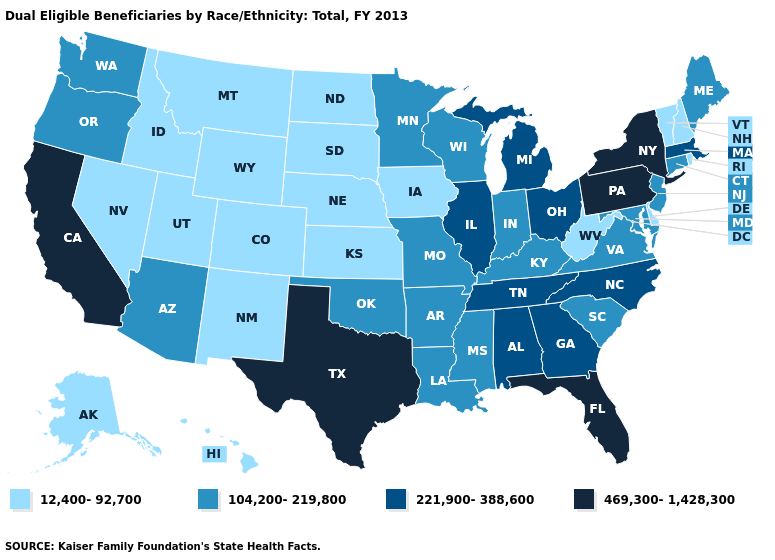What is the value of Colorado?
Give a very brief answer. 12,400-92,700. What is the value of Massachusetts?
Give a very brief answer. 221,900-388,600. Name the states that have a value in the range 469,300-1,428,300?
Concise answer only. California, Florida, New York, Pennsylvania, Texas. What is the value of Alaska?
Short answer required. 12,400-92,700. How many symbols are there in the legend?
Short answer required. 4. Among the states that border Colorado , which have the lowest value?
Short answer required. Kansas, Nebraska, New Mexico, Utah, Wyoming. Name the states that have a value in the range 221,900-388,600?
Give a very brief answer. Alabama, Georgia, Illinois, Massachusetts, Michigan, North Carolina, Ohio, Tennessee. Which states have the lowest value in the MidWest?
Write a very short answer. Iowa, Kansas, Nebraska, North Dakota, South Dakota. Which states have the lowest value in the South?
Write a very short answer. Delaware, West Virginia. What is the value of New Mexico?
Be succinct. 12,400-92,700. What is the value of South Carolina?
Write a very short answer. 104,200-219,800. What is the lowest value in the USA?
Give a very brief answer. 12,400-92,700. What is the value of Utah?
Write a very short answer. 12,400-92,700. Does Pennsylvania have the highest value in the USA?
Short answer required. Yes. Among the states that border North Carolina , does South Carolina have the lowest value?
Write a very short answer. Yes. 